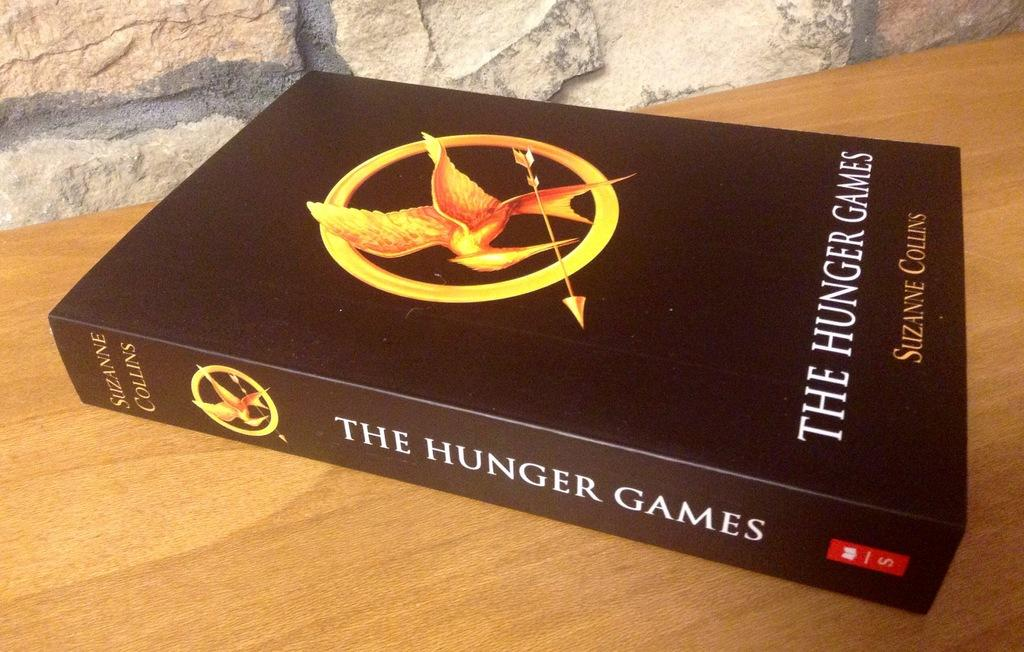What is the color of the book in the image? The book in the image is brown. Where is the book placed? The book is placed on a cream color table. What color are the words on the book? The words on the book are white. What can be seen in the background of the image? There is a wall in the background of the image. What type of plant is growing on the canvas in the image? There is no plant or canvas present in the image. 